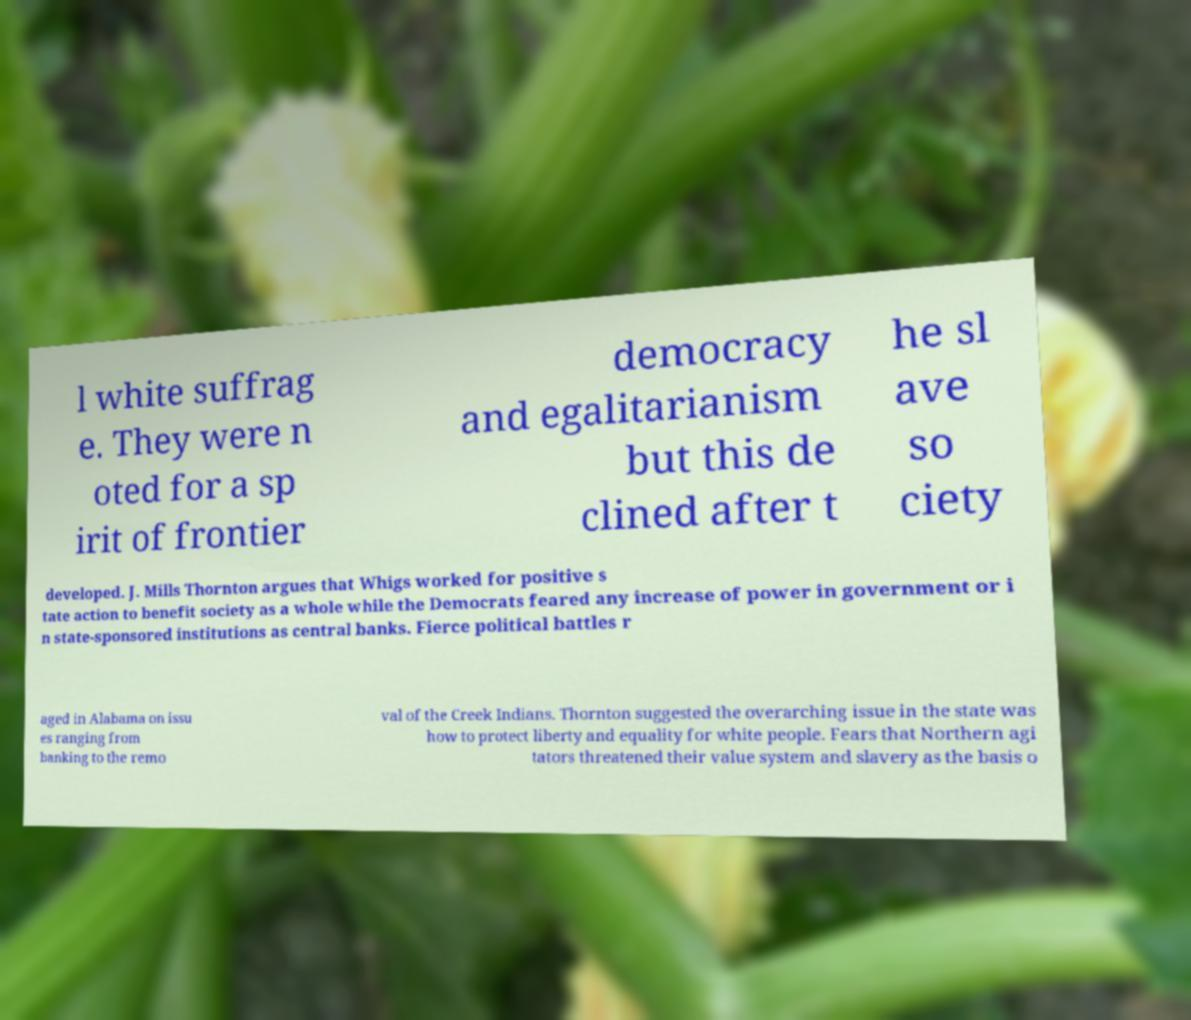Could you extract and type out the text from this image? l white suffrag e. They were n oted for a sp irit of frontier democracy and egalitarianism but this de clined after t he sl ave so ciety developed. J. Mills Thornton argues that Whigs worked for positive s tate action to benefit society as a whole while the Democrats feared any increase of power in government or i n state-sponsored institutions as central banks. Fierce political battles r aged in Alabama on issu es ranging from banking to the remo val of the Creek Indians. Thornton suggested the overarching issue in the state was how to protect liberty and equality for white people. Fears that Northern agi tators threatened their value system and slavery as the basis o 